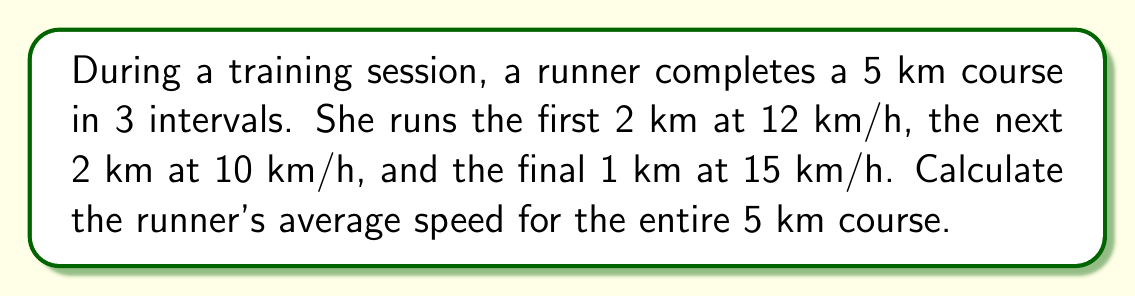Help me with this question. To calculate the average speed, we need to find the total distance and total time, then divide distance by time.

1. Calculate the time for each interval:
   - First interval: $t_1 = \frac{2 \text{ km}}{12 \text{ km/h}} = \frac{1}{6} \text{ h} = 10 \text{ min}$
   - Second interval: $t_2 = \frac{2 \text{ km}}{10 \text{ km/h}} = \frac{1}{5} \text{ h} = 12 \text{ min}$
   - Third interval: $t_3 = \frac{1 \text{ km}}{15 \text{ km/h}} = \frac{1}{15} \text{ h} = 4 \text{ min}$

2. Calculate the total time:
   $t_{\text{total}} = 10 + 12 + 4 = 26 \text{ min} = \frac{13}{30} \text{ h}$

3. Calculate the average speed:
   $$\text{Average Speed} = \frac{\text{Total Distance}}{\text{Total Time}} = \frac{5 \text{ km}}{\frac{13}{30} \text{ h}} = \frac{5 \cdot 30}{13} \text{ km/h} = \frac{150}{13} \text{ km/h} \approx 11.54 \text{ km/h}$$
Answer: $\frac{150}{13} \text{ km/h}$ or approximately 11.54 km/h 